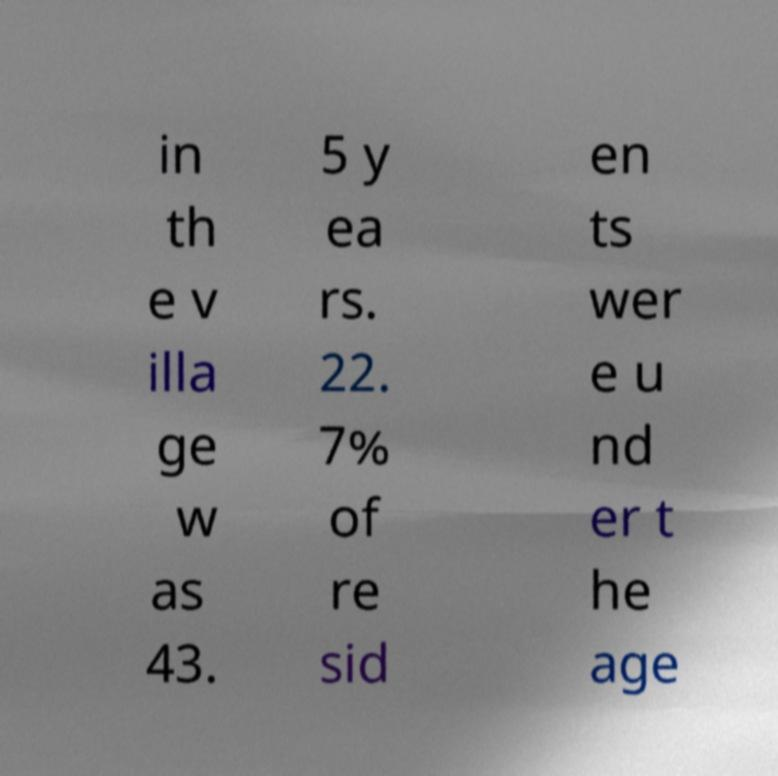I need the written content from this picture converted into text. Can you do that? in th e v illa ge w as 43. 5 y ea rs. 22. 7% of re sid en ts wer e u nd er t he age 